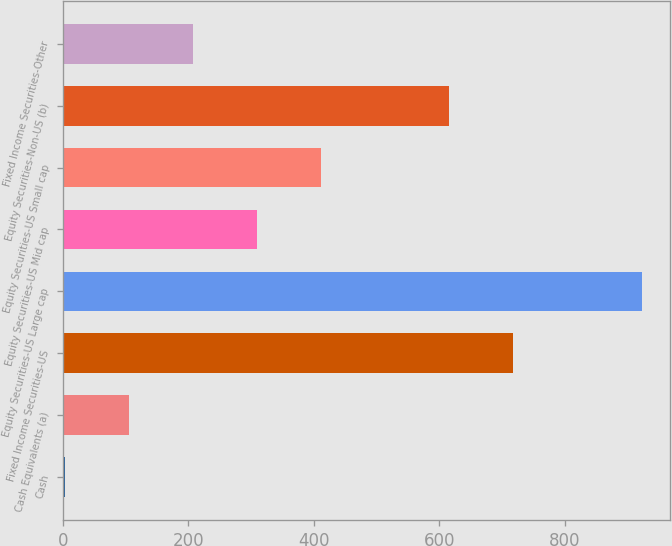Convert chart. <chart><loc_0><loc_0><loc_500><loc_500><bar_chart><fcel>Cash<fcel>Cash Equivalents (a)<fcel>Fixed Income Securities-US<fcel>Equity Securities-US Large cap<fcel>Equity Securities-US Mid cap<fcel>Equity Securities-US Small cap<fcel>Equity Securities-Non-US (b)<fcel>Fixed Income Securities-Other<nl><fcel>3<fcel>105.1<fcel>717.7<fcel>921.9<fcel>309.3<fcel>411.4<fcel>615.6<fcel>207.2<nl></chart> 